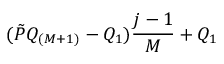Convert formula to latex. <formula><loc_0><loc_0><loc_500><loc_500>( \tilde { P } Q _ { ( M + 1 ) } - Q _ { 1 } ) \frac { j - 1 } { M } + Q _ { 1 }</formula> 